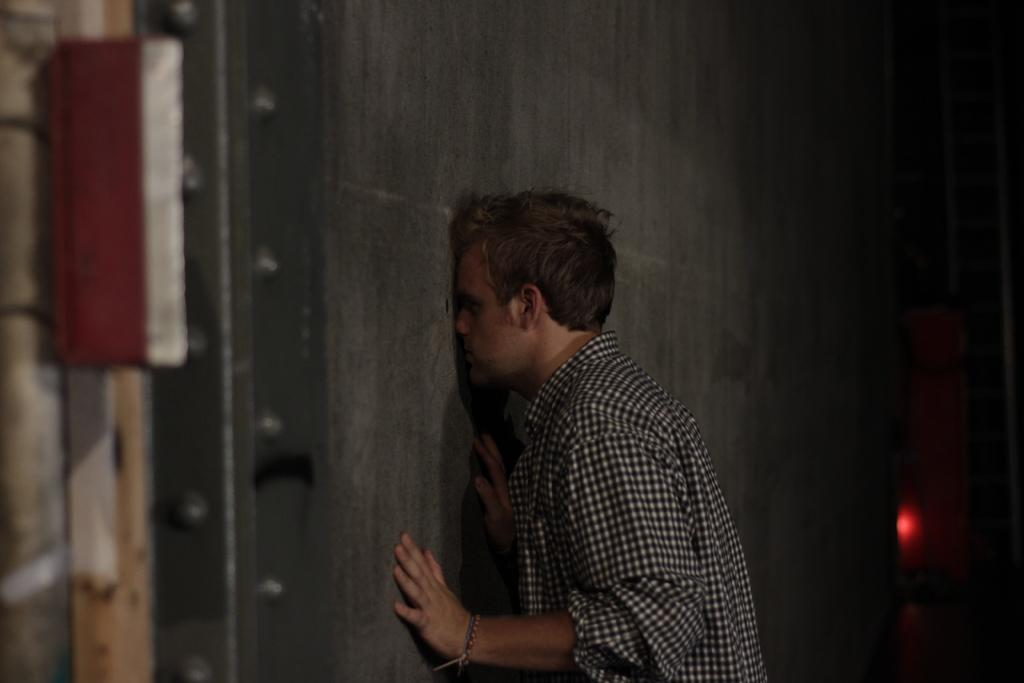What can be seen in the image? There is a person in the image. What is the person wearing? The person is wearing a shirt. Where is the person located in the image? The person is standing near a wall. Can you describe the quality of the image? The image is slightly blurred in some parts and dark in some parts. What type of horn can be seen on the jellyfish in the image? There is no jellyfish or horn present in the image. 